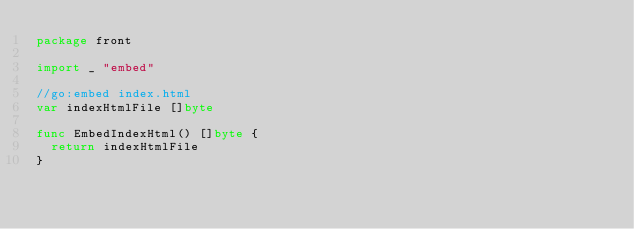<code> <loc_0><loc_0><loc_500><loc_500><_Go_>package front

import _ "embed"

//go:embed index.html
var indexHtmlFile []byte

func EmbedIndexHtml() []byte {
	return indexHtmlFile
}
</code> 